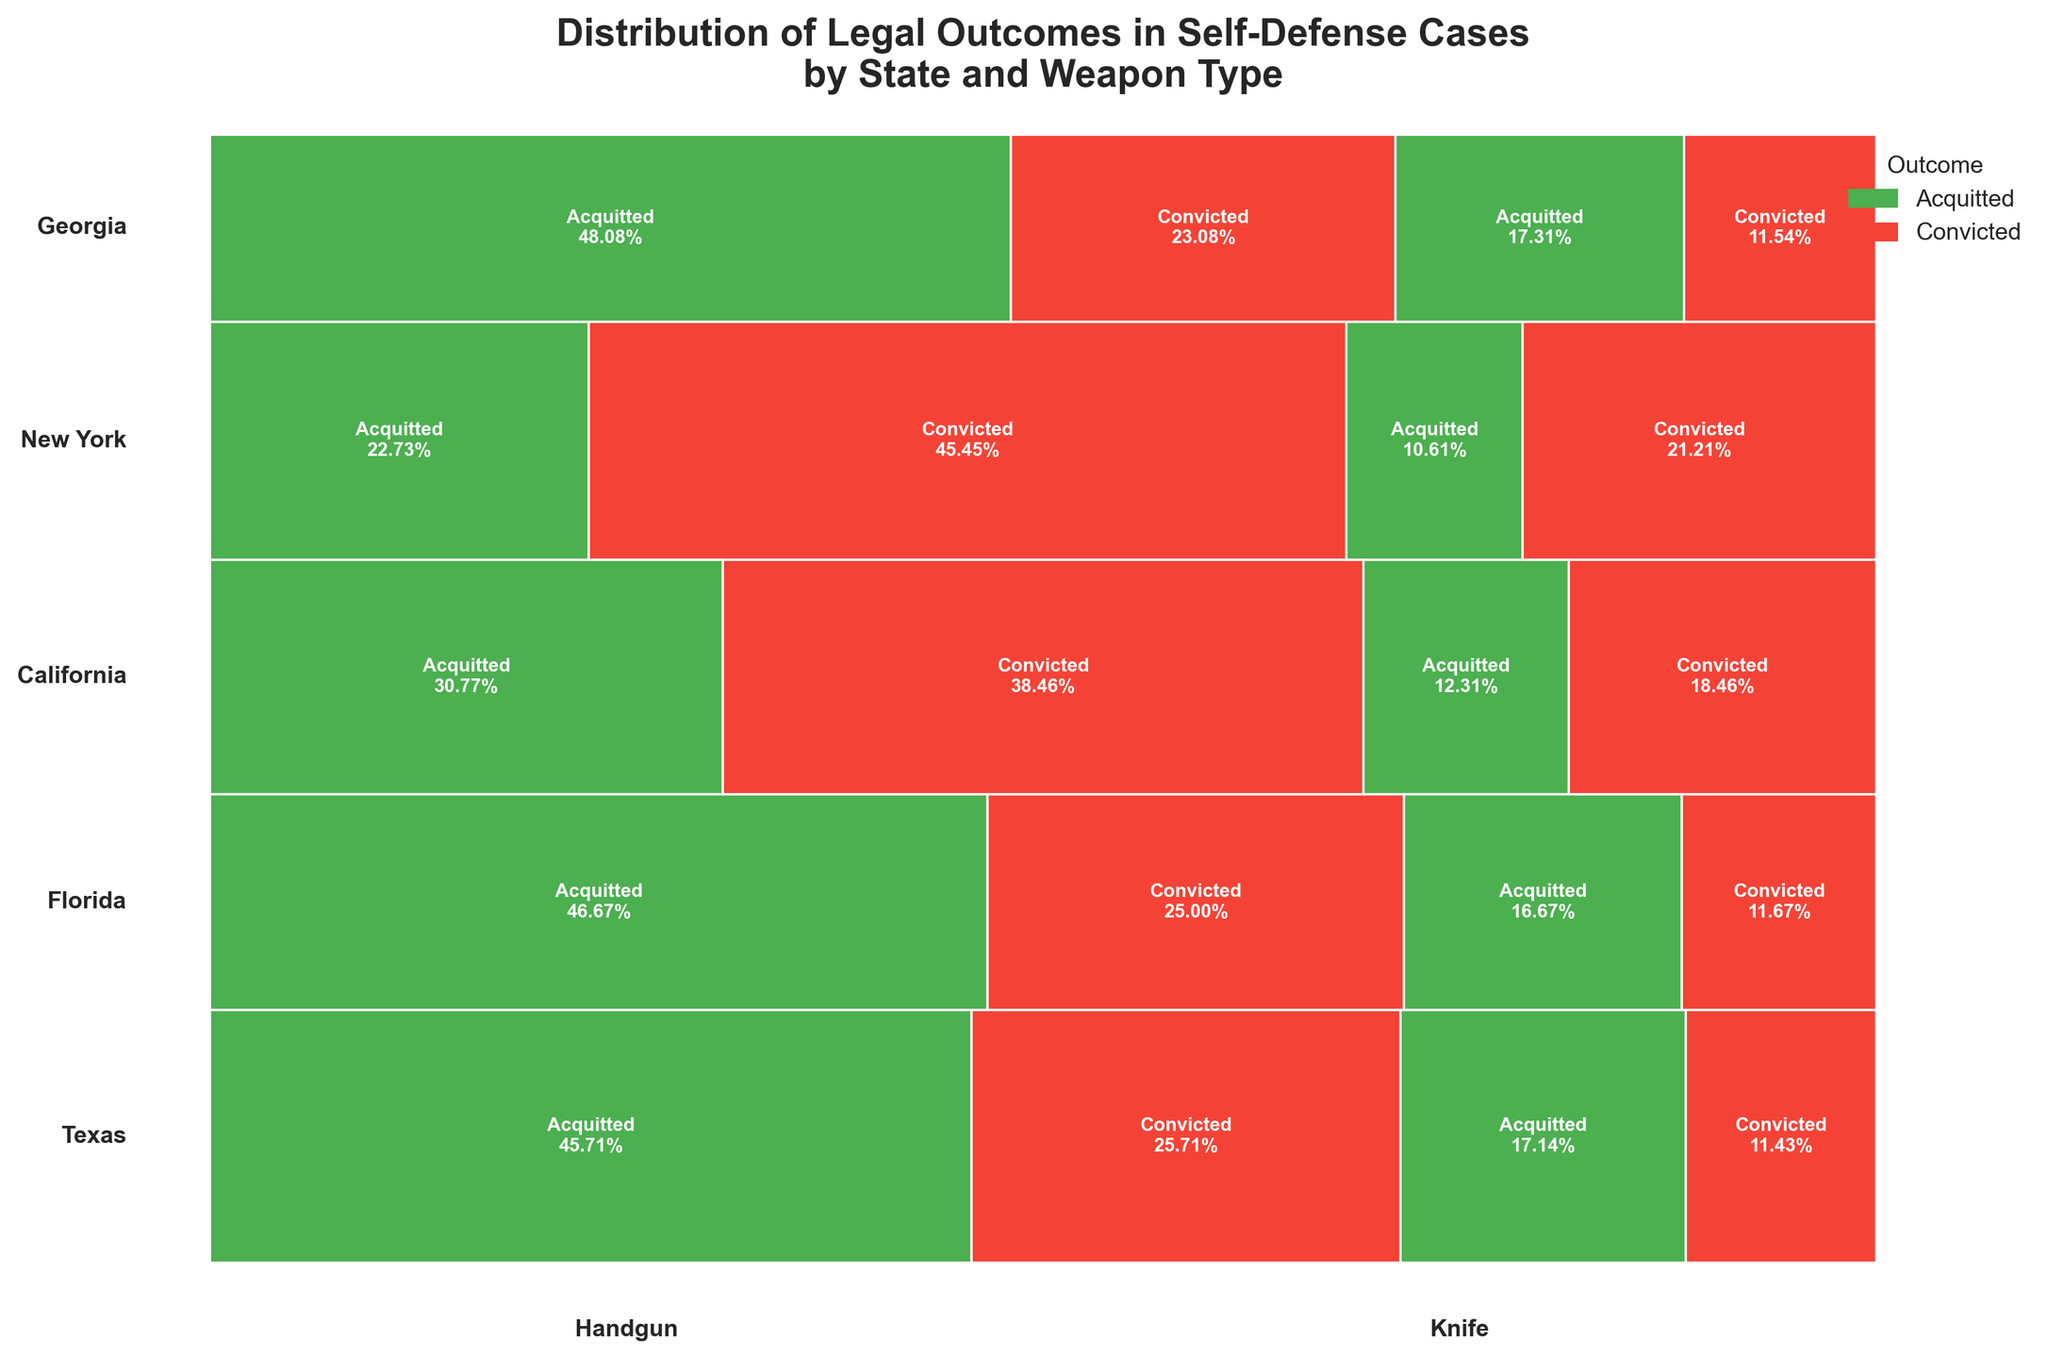What is the title of the plot? The title is usually displayed at the top center of the plot and presents a summary of the figure. In this case, the title is "Distribution of Legal Outcomes in Self-Defense Cases by State and Weapon Type".
Answer: Distribution of Legal Outcomes in Self-Defense Cases by State and Weapon Type Which state has the highest number of acquittals for handgun use? By looking at the proportions of the green sections (representing acquittals) for handguns across different states, we can identify which one has the most. Texas has the largest green section for handguns.
Answer: Texas In which state do knife-related self-defense cases have a higher conviction rate than acquittal rate? For each state, we compare the sizes of the red (convicted) and green (acquitted) sections for knife use. In New York, the red section is significantly larger than the green section for knife-related cases.
Answer: New York Compare the conviction rates for handgun use in California and Florida. Which state has a higher rate? We need to look at the red sections (convicted) for handgun use in both states and compare their proportions. The red section for handguns is larger in California than in Florida.
Answer: California Which state has the most evenly balanced outcomes (acquitted vs. convicted) for knife use? We look at the states' knife-related outcomes and identify which has the most similar proportions of green (acquitted) and red (convicted). Georgia shows the most balance between the two outcomes for knife use.
Answer: Georgia What weapon type in Texas has a higher acquittal rate, a handgun or a knife? By comparing the proportion sizes of the green sections for both handgun and knife in Texas, we can determine which has a higher acquittal rate. Handguns have a larger green section than knives in Texas.
Answer: Handgun How does the conviction rate for handgun use in New York compare with California? By comparing the sizes of the red sections for handgun use in both states, we find that New York has a larger red section, indicating a higher conviction rate.
Answer: New York Which state has the lowest overall proportion of convicted self-defense cases? We look at the total size of the red sections across all weapon types in each state. Texas has the smallest overall red section, indicating the lowest conviction rate.
Answer: Texas In Florida, which outcome is more common for knife-related self-defense cases? By observing the relative sizes of the green (acquitted) and red (convicted) sections for knife use in Florida, we can determine which is more common. The green section is larger, indicating that acquittal is more common.
Answer: Acquitted 